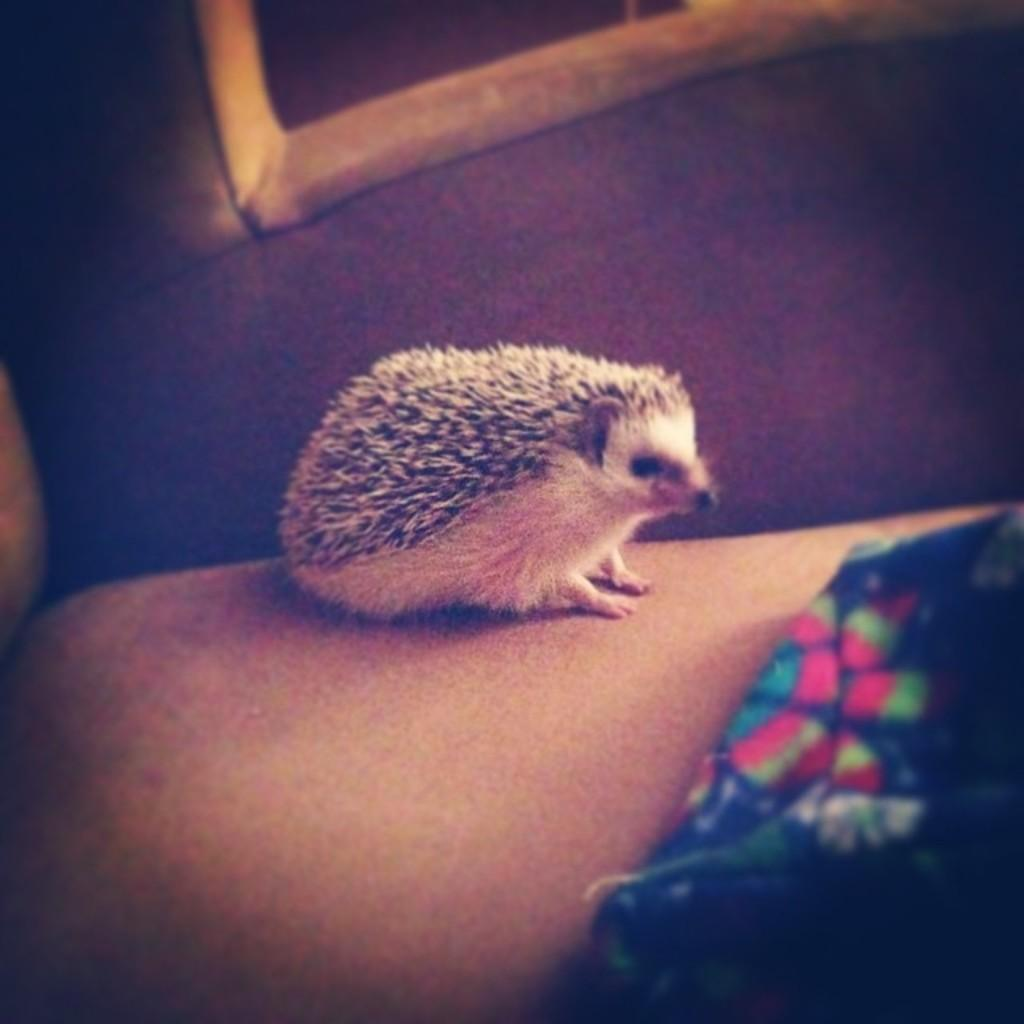What type of creature is present in the image? There is an animal in the image. Can you describe the animal's location in the image? The animal is on the surface in the image. What type of stocking is the animal wearing in the image? There is no stocking present in the image, and the animal is not wearing any clothing. 